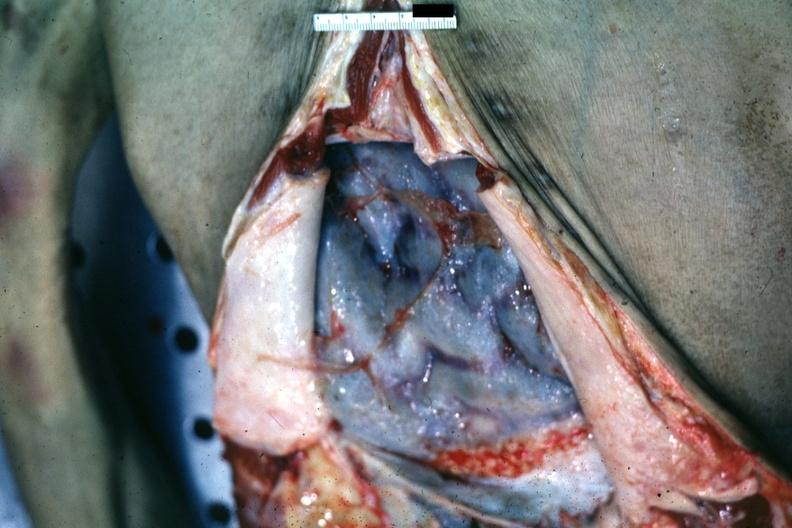what is present?
Answer the question using a single word or phrase. Peritoneum 